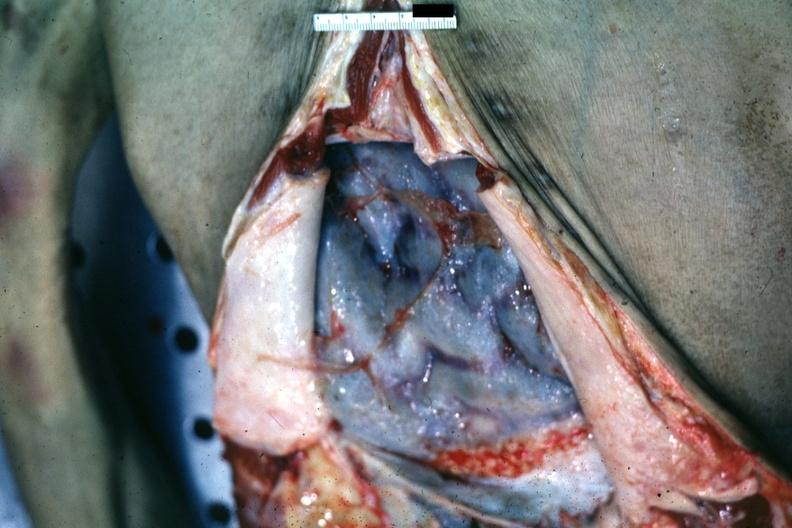what is present?
Answer the question using a single word or phrase. Peritoneum 